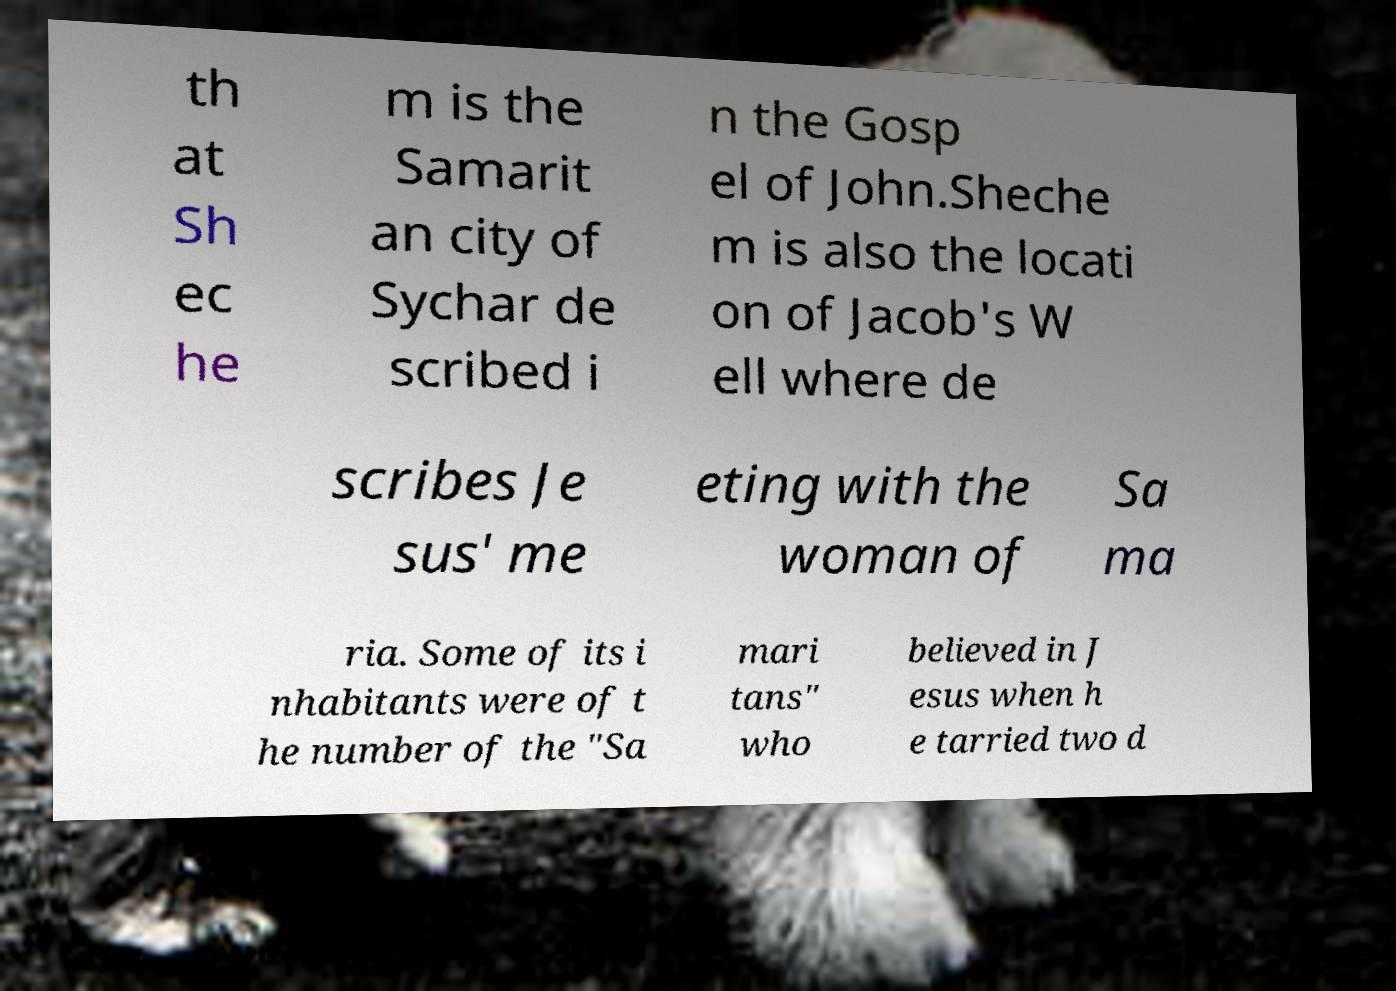Can you read and provide the text displayed in the image?This photo seems to have some interesting text. Can you extract and type it out for me? th at Sh ec he m is the Samarit an city of Sychar de scribed i n the Gosp el of John.Sheche m is also the locati on of Jacob's W ell where de scribes Je sus' me eting with the woman of Sa ma ria. Some of its i nhabitants were of t he number of the "Sa mari tans" who believed in J esus when h e tarried two d 